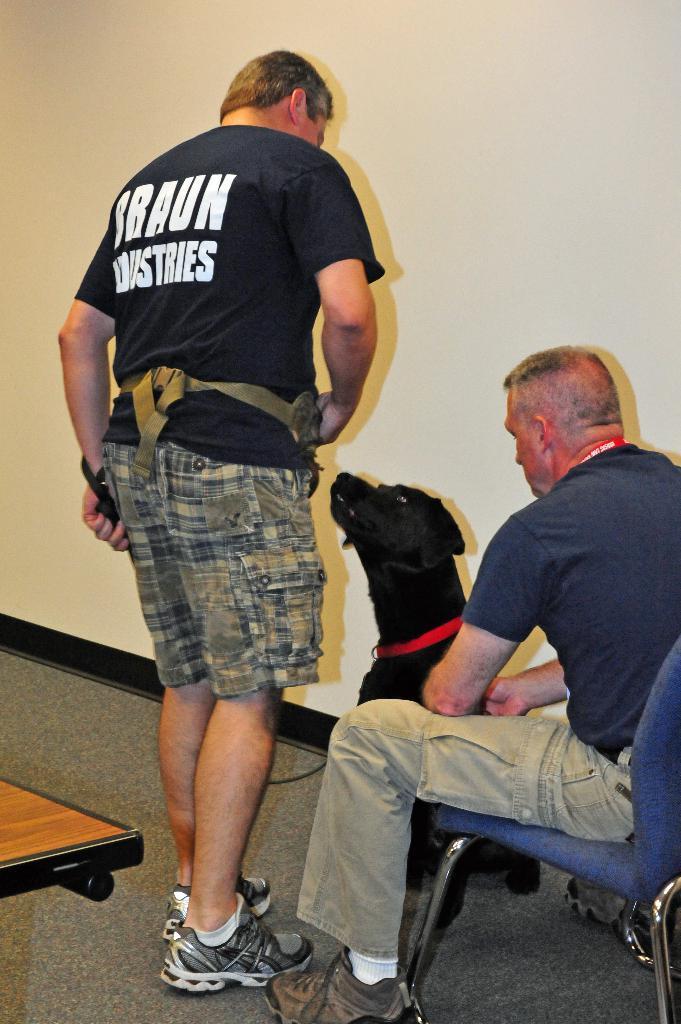Can you describe this image briefly? In this picture I can see a man sitting in the chair and I can see another man standing and holding a dog with the help of a string and looks like a table on the left side and I can see a wall in the back. 